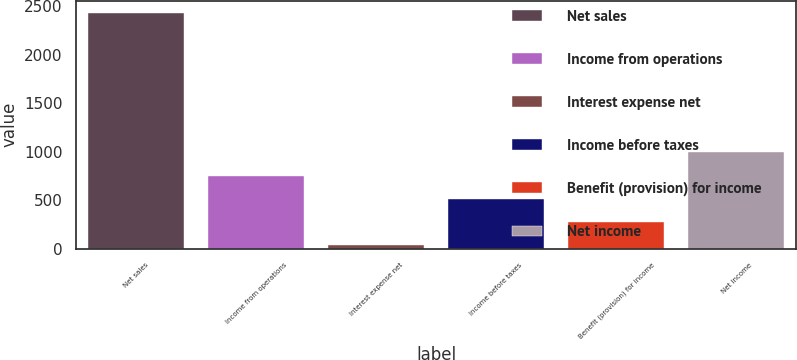<chart> <loc_0><loc_0><loc_500><loc_500><bar_chart><fcel>Net sales<fcel>Income from operations<fcel>Interest expense net<fcel>Income before taxes<fcel>Benefit (provision) for income<fcel>Net income<nl><fcel>2435.6<fcel>753.29<fcel>32.3<fcel>512.96<fcel>272.63<fcel>993.62<nl></chart> 